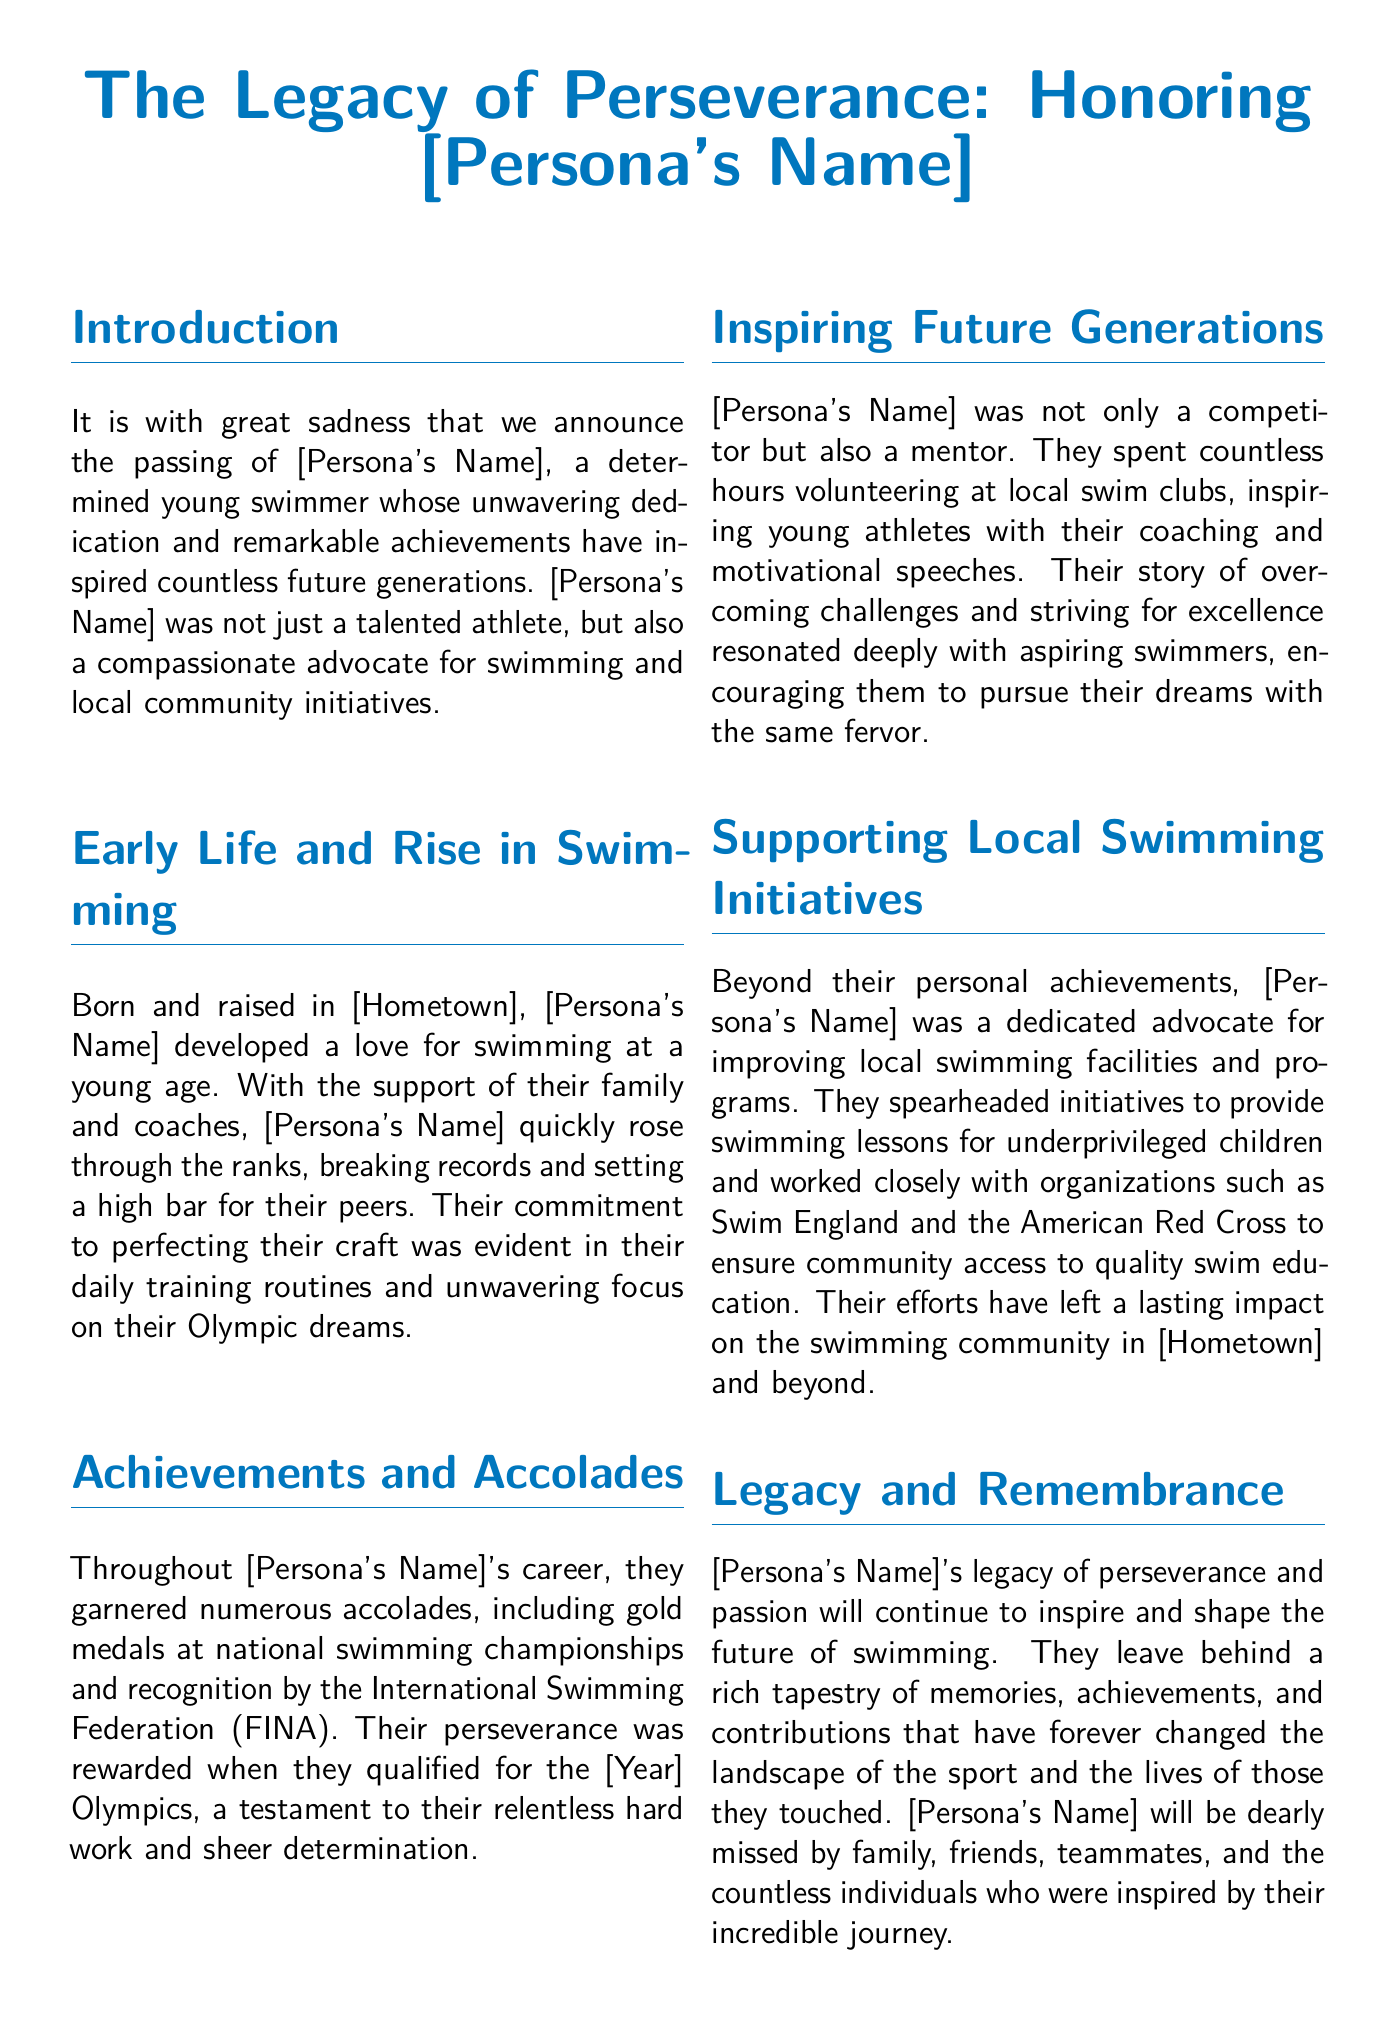what was the name of the swimmer? The document refers to the swimmer as [Persona's Name], a placeholder for the actual name.
Answer: [Persona's Name] what achievements did the swimmer receive? The document states that the swimmer garnered numerous accolades, including gold medals at national swimming championships and recognition by the International Swimming Federation (FINA).
Answer: gold medals in which year did the swimmer qualify for the Olympics? The document indicates that the swimmer qualified for the [Year] Olympics, which is a placeholder for the actual year.
Answer: [Year] what was the swimmer's hometown? The swimmer's hometown is represented by a placeholder [Hometown] in the document.
Answer: [Hometown] what was one of the swimmer's contributions to the community? The document mentions that the swimmer spearheaded initiatives to provide swimming lessons for underprivileged children.
Answer: swimming lessons what impact did the swimmer's story have on young athletes? The swimmer's story encouraged aspiring swimmers to pursue their dreams with fervor.
Answer: encouraged aspirations what quote is attributed to the swimmer in the document? The document features a quote about sharing the spirit of water that is attributed to the swimmer.
Answer: "The water is your friend..." how did the swimmer support local swimming initiatives? The swimmer worked closely with organizations such as Swim England and the American Red Cross to improve local swim education.
Answer: worked closely with organizations what overall legacy did the swimmer leave behind? The document emphasizes that the swimmer's legacy of perseverance and passion will continue to inspire the future of swimming.
Answer: perseverance and passion 